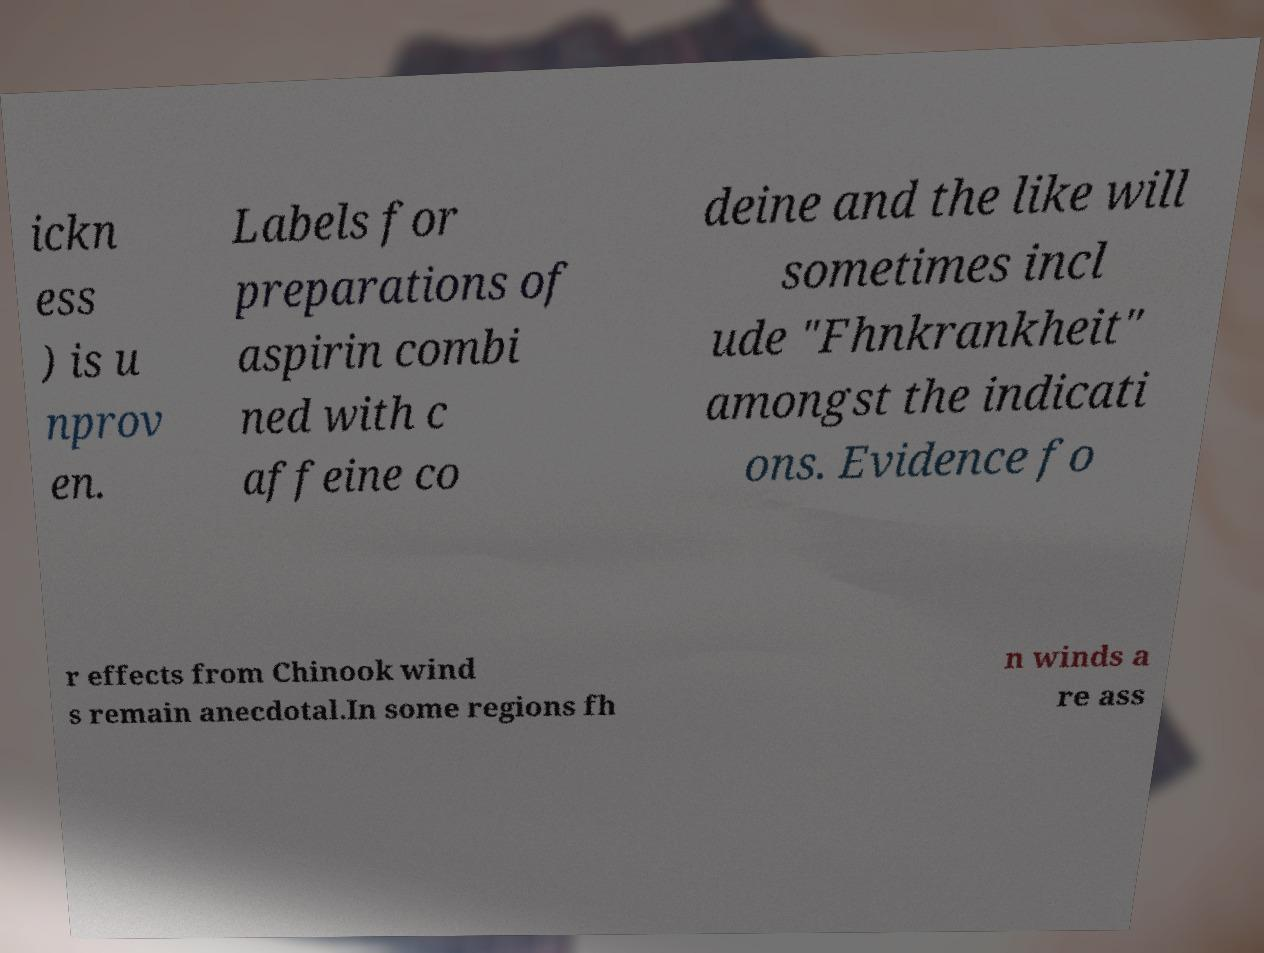Could you assist in decoding the text presented in this image and type it out clearly? ickn ess ) is u nprov en. Labels for preparations of aspirin combi ned with c affeine co deine and the like will sometimes incl ude "Fhnkrankheit" amongst the indicati ons. Evidence fo r effects from Chinook wind s remain anecdotal.In some regions fh n winds a re ass 